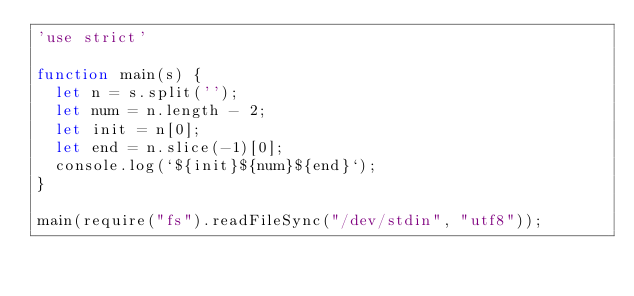Convert code to text. <code><loc_0><loc_0><loc_500><loc_500><_JavaScript_>'use strict'
 
function main(s) {
  let n = s.split('');
  let num = n.length - 2;
  let init = n[0];
  let end = n.slice(-1)[0];
  console.log(`${init}${num}${end}`);
}
 
main(require("fs").readFileSync("/dev/stdin", "utf8"));</code> 